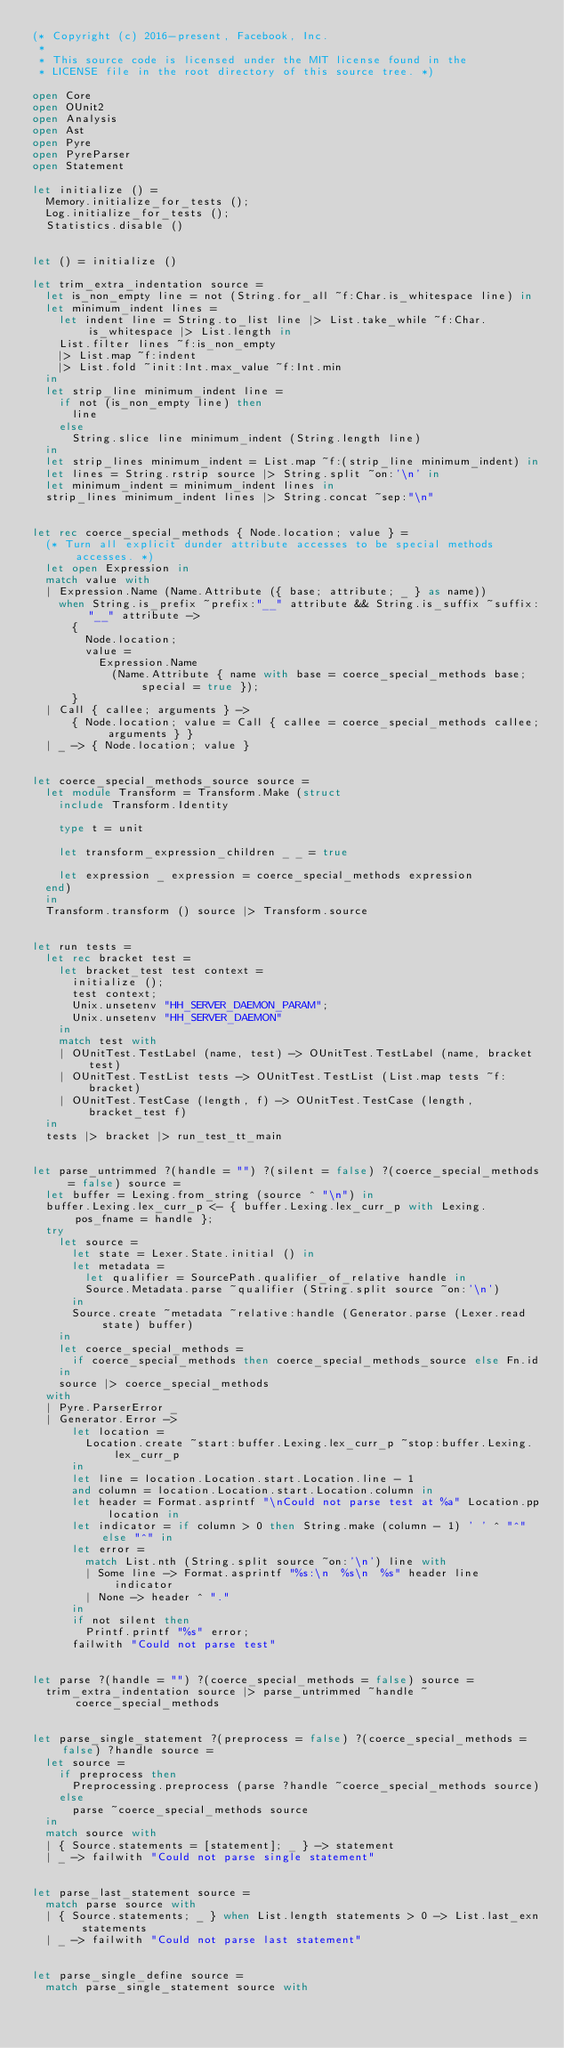<code> <loc_0><loc_0><loc_500><loc_500><_OCaml_>(* Copyright (c) 2016-present, Facebook, Inc.
 *
 * This source code is licensed under the MIT license found in the
 * LICENSE file in the root directory of this source tree. *)

open Core
open OUnit2
open Analysis
open Ast
open Pyre
open PyreParser
open Statement

let initialize () =
  Memory.initialize_for_tests ();
  Log.initialize_for_tests ();
  Statistics.disable ()


let () = initialize ()

let trim_extra_indentation source =
  let is_non_empty line = not (String.for_all ~f:Char.is_whitespace line) in
  let minimum_indent lines =
    let indent line = String.to_list line |> List.take_while ~f:Char.is_whitespace |> List.length in
    List.filter lines ~f:is_non_empty
    |> List.map ~f:indent
    |> List.fold ~init:Int.max_value ~f:Int.min
  in
  let strip_line minimum_indent line =
    if not (is_non_empty line) then
      line
    else
      String.slice line minimum_indent (String.length line)
  in
  let strip_lines minimum_indent = List.map ~f:(strip_line minimum_indent) in
  let lines = String.rstrip source |> String.split ~on:'\n' in
  let minimum_indent = minimum_indent lines in
  strip_lines minimum_indent lines |> String.concat ~sep:"\n"


let rec coerce_special_methods { Node.location; value } =
  (* Turn all explicit dunder attribute accesses to be special methods accesses. *)
  let open Expression in
  match value with
  | Expression.Name (Name.Attribute ({ base; attribute; _ } as name))
    when String.is_prefix ~prefix:"__" attribute && String.is_suffix ~suffix:"__" attribute ->
      {
        Node.location;
        value =
          Expression.Name
            (Name.Attribute { name with base = coerce_special_methods base; special = true });
      }
  | Call { callee; arguments } ->
      { Node.location; value = Call { callee = coerce_special_methods callee; arguments } }
  | _ -> { Node.location; value }


let coerce_special_methods_source source =
  let module Transform = Transform.Make (struct
    include Transform.Identity

    type t = unit

    let transform_expression_children _ _ = true

    let expression _ expression = coerce_special_methods expression
  end)
  in
  Transform.transform () source |> Transform.source


let run tests =
  let rec bracket test =
    let bracket_test test context =
      initialize ();
      test context;
      Unix.unsetenv "HH_SERVER_DAEMON_PARAM";
      Unix.unsetenv "HH_SERVER_DAEMON"
    in
    match test with
    | OUnitTest.TestLabel (name, test) -> OUnitTest.TestLabel (name, bracket test)
    | OUnitTest.TestList tests -> OUnitTest.TestList (List.map tests ~f:bracket)
    | OUnitTest.TestCase (length, f) -> OUnitTest.TestCase (length, bracket_test f)
  in
  tests |> bracket |> run_test_tt_main


let parse_untrimmed ?(handle = "") ?(silent = false) ?(coerce_special_methods = false) source =
  let buffer = Lexing.from_string (source ^ "\n") in
  buffer.Lexing.lex_curr_p <- { buffer.Lexing.lex_curr_p with Lexing.pos_fname = handle };
  try
    let source =
      let state = Lexer.State.initial () in
      let metadata =
        let qualifier = SourcePath.qualifier_of_relative handle in
        Source.Metadata.parse ~qualifier (String.split source ~on:'\n')
      in
      Source.create ~metadata ~relative:handle (Generator.parse (Lexer.read state) buffer)
    in
    let coerce_special_methods =
      if coerce_special_methods then coerce_special_methods_source else Fn.id
    in
    source |> coerce_special_methods
  with
  | Pyre.ParserError _
  | Generator.Error ->
      let location =
        Location.create ~start:buffer.Lexing.lex_curr_p ~stop:buffer.Lexing.lex_curr_p
      in
      let line = location.Location.start.Location.line - 1
      and column = location.Location.start.Location.column in
      let header = Format.asprintf "\nCould not parse test at %a" Location.pp location in
      let indicator = if column > 0 then String.make (column - 1) ' ' ^ "^" else "^" in
      let error =
        match List.nth (String.split source ~on:'\n') line with
        | Some line -> Format.asprintf "%s:\n  %s\n  %s" header line indicator
        | None -> header ^ "."
      in
      if not silent then
        Printf.printf "%s" error;
      failwith "Could not parse test"


let parse ?(handle = "") ?(coerce_special_methods = false) source =
  trim_extra_indentation source |> parse_untrimmed ~handle ~coerce_special_methods


let parse_single_statement ?(preprocess = false) ?(coerce_special_methods = false) ?handle source =
  let source =
    if preprocess then
      Preprocessing.preprocess (parse ?handle ~coerce_special_methods source)
    else
      parse ~coerce_special_methods source
  in
  match source with
  | { Source.statements = [statement]; _ } -> statement
  | _ -> failwith "Could not parse single statement"


let parse_last_statement source =
  match parse source with
  | { Source.statements; _ } when List.length statements > 0 -> List.last_exn statements
  | _ -> failwith "Could not parse last statement"


let parse_single_define source =
  match parse_single_statement source with</code> 